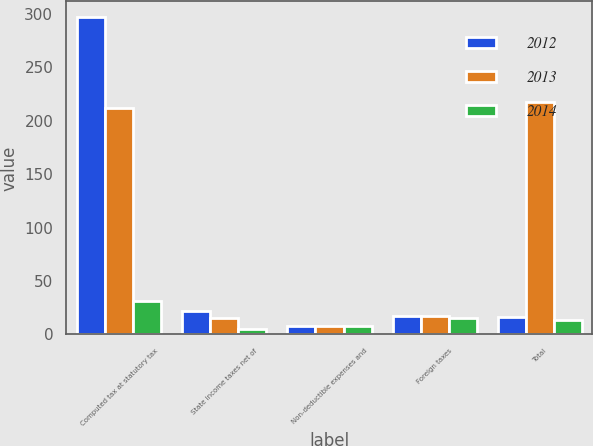Convert chart to OTSL. <chart><loc_0><loc_0><loc_500><loc_500><stacked_bar_chart><ecel><fcel>Computed tax at statutory tax<fcel>State income taxes net of<fcel>Non-deductible expenses and<fcel>Foreign taxes<fcel>Total<nl><fcel>2012<fcel>297<fcel>22<fcel>8<fcel>17<fcel>16<nl><fcel>2013<fcel>212<fcel>15<fcel>8<fcel>17<fcel>218<nl><fcel>2014<fcel>31<fcel>5<fcel>8<fcel>15<fcel>13<nl></chart> 